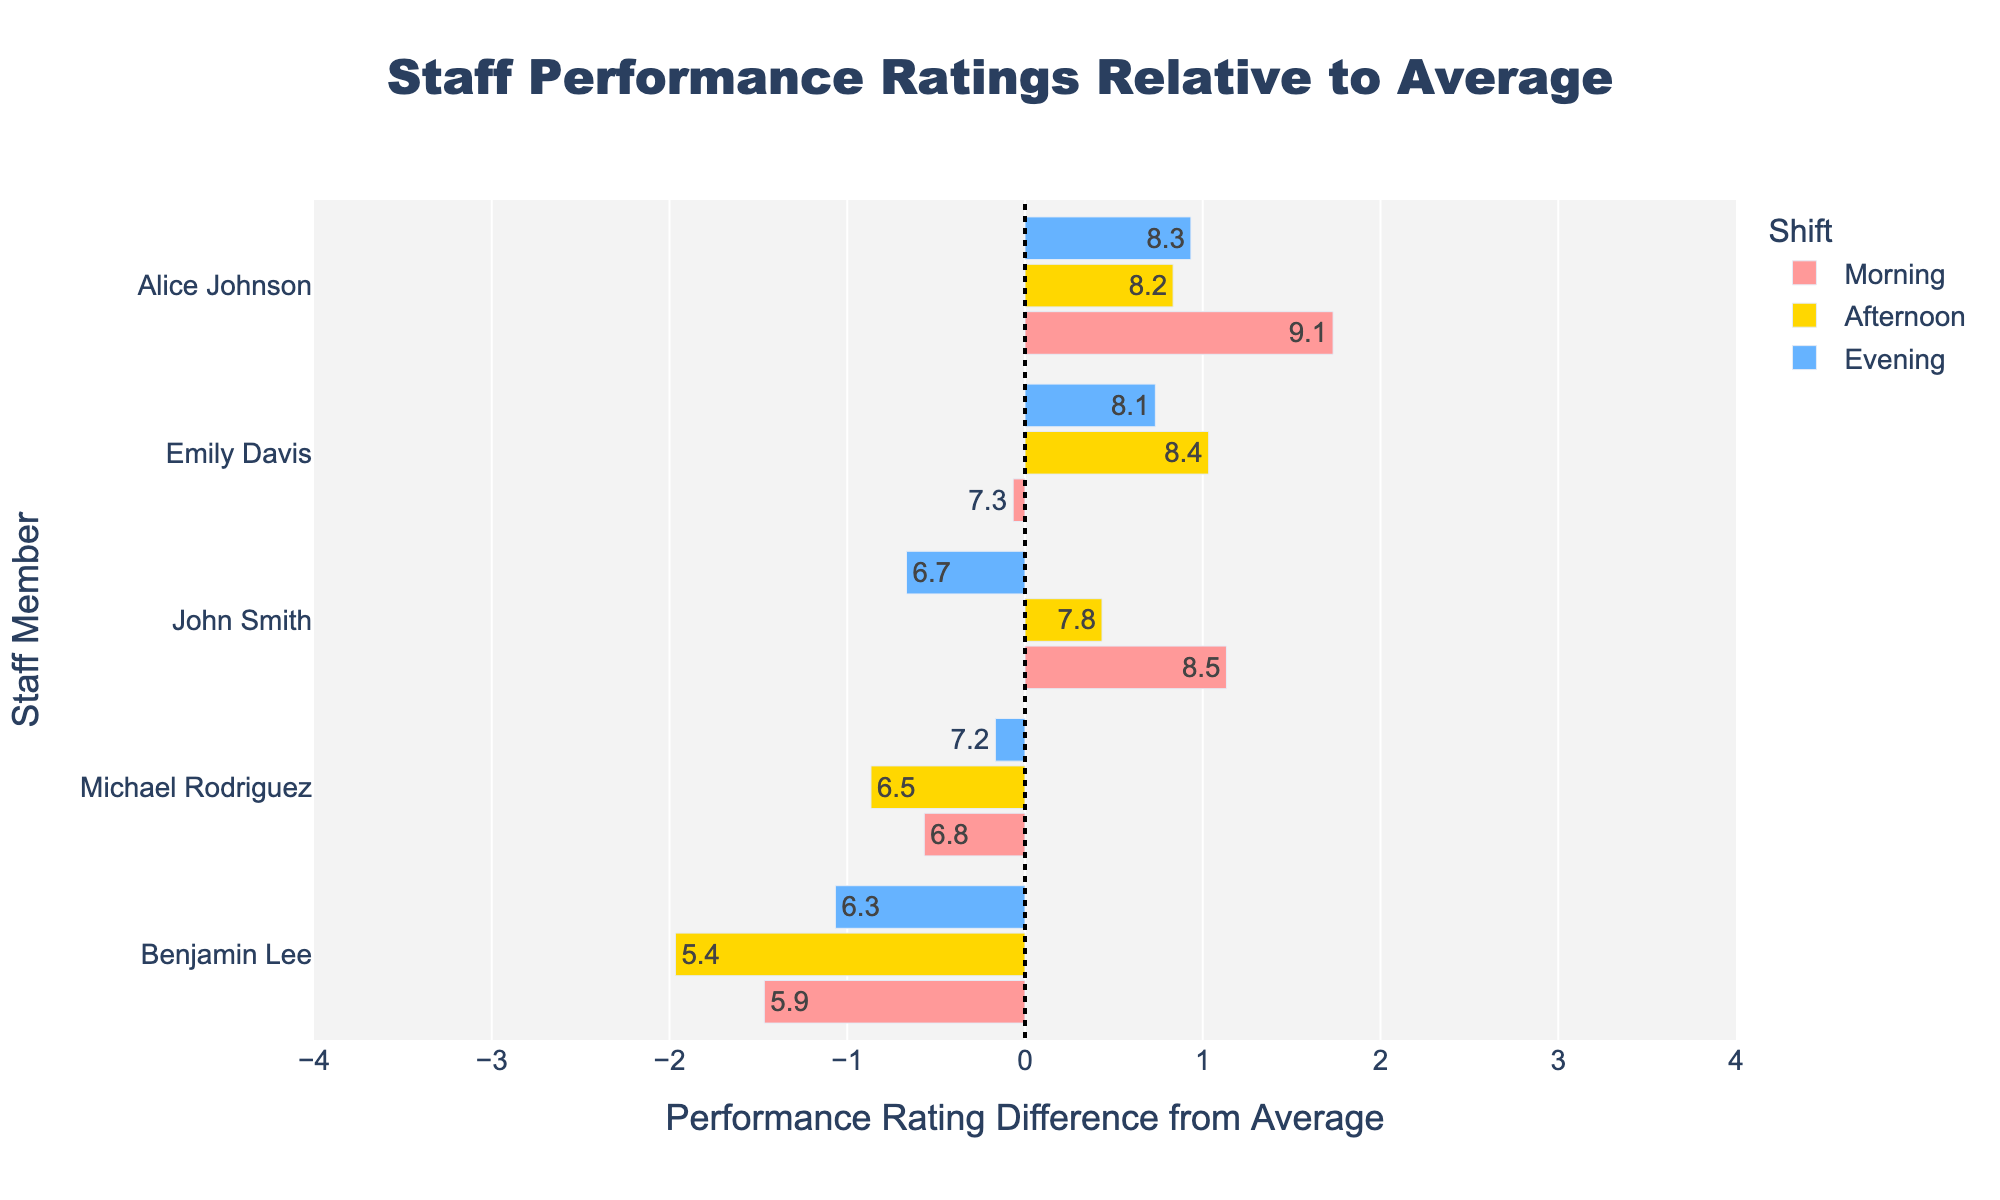What's the name of the morning shift staff member with the highest performance rating? The morning shift data shows that Alice Johnson has the highest performance rating at 9.1.
Answer: Alice Johnson What is the difference in performance rating between Emily Davis's morning and evening shifts? Emily Davis has a performance rating of 7.3 in the morning and 8.1 in the evening. The difference is 8.1 - 7.3 = 0.8.
Answer: 0.8 Who had the lowest performance rating in the afternoon shift? The lowest performance rating in the afternoon shift is 5.4 for Benjamin Lee.
Answer: Benjamin Lee Which staff member has the most consistent performance across all shifts? The staff rating data across shifts show minimal variation for Emily Davis, with ratings of 7.3, 8.4, and 8.1.
Answer: Emily Davis In which shift did John Smith perform below the average performance rating? The average performance rating can be calculated first. John Smith's ratings are 8.5 (Morning), 7.8 (Afternoon), and 6.7 (Evening). The overall average rating is (8.5 + 7.3 + 6.8 + 9.1 + 5.9 + 7.8 + 8.4 + 6.5 + 8.2 + 5.4 + 6.7 + 8.1 + 7.2 + 8.3 + 6.3) / 15 = 7.28. John Smith's evening rating of 6.7 is below this average.
Answer: Evening What is the average performance rating for the morning shift? The ratings for the morning shift are 8.5, 7.3, 6.8, 9.1, and 5.9. The sum is 8.5 + 7.3 + 6.8 + 9.1 + 5.9 = 37.6. Dividing by 5 gives 37.6 / 5 = 7.52.
Answer: 7.52 What is the overall trend in performance across shifts for Michael Rodriguez? Michael Rodriguez has a performance rating of 6.8 (Morning), 6.5 (Afternoon), and 7.2 (Evening). This indicates a slight decrease from morning to afternoon, followed by an increase in the evening.
Answer: Decrease then increase Which shift has the most diverse range of staff performance ratings? The range is calculated by subtracting the lowest rating from the highest rating per shift. Morning: 9.1-5.9=3.2, Afternoon: 8.4-5.4=3, Evening: 8.3-6.3=2. The morning shift has the highest range.
Answer: Morning Are there more staff members performing above average or below average in the morning shift? The average rating is 7.28. Morning ratings are 8.5, 7.3, 6.8, 9.1, & 5.9. Ratings above 7.28: 8.5, 7.3, 9.1 (3 members). Ratings below 7.28: 6.8, 5.9 (2 members). Thus, more staff members are performing above average in the morning shift.
Answer: Above average Which shift shows the highest maximum performance rating and who holds it? All shifts' max ratings: Morning: 9.1 (Alice Johnson), Afternoon: 8.4 (Emily Davis), Evening: 8.3 (Alice Johnson). The highest is 9.1 in the morning by Alice Johnson.
Answer: Morning, Alice Johnson 